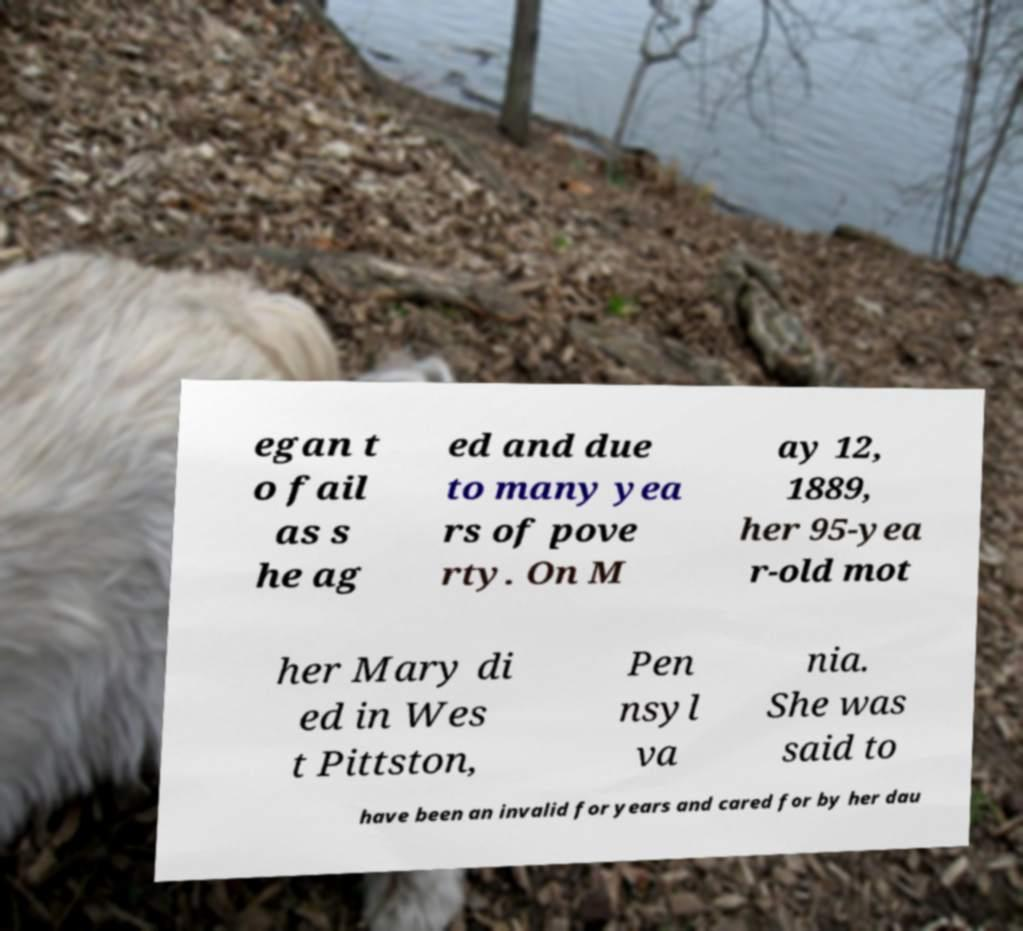What messages or text are displayed in this image? I need them in a readable, typed format. egan t o fail as s he ag ed and due to many yea rs of pove rty. On M ay 12, 1889, her 95-yea r-old mot her Mary di ed in Wes t Pittston, Pen nsyl va nia. She was said to have been an invalid for years and cared for by her dau 